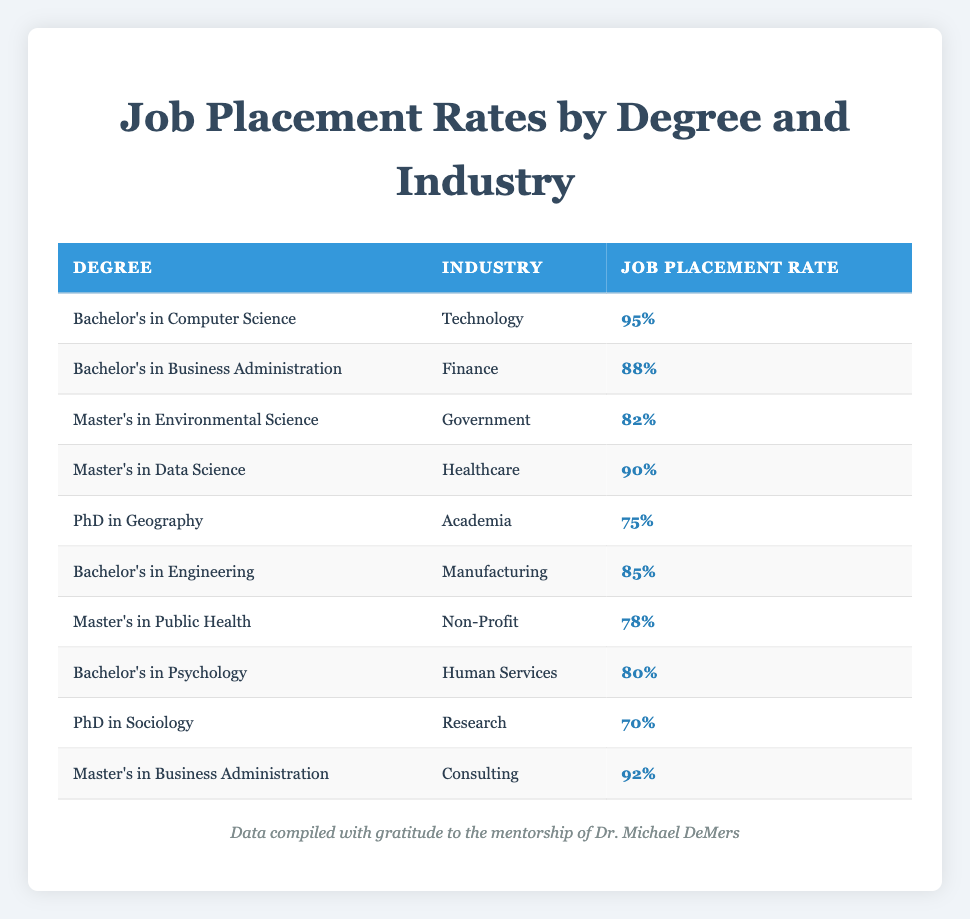What is the job placement rate for Bachelor's in Computer Science? The table lists the job placement rate for Bachelor's in Computer Science as 95%, which can be directly found in the corresponding row of the table.
Answer: 95% Which degree has the highest job placement rate? By examining the job placement rates in the table, Bachelor's in Computer Science has the highest rate of 95%, which is greater than all other rates listed.
Answer: Bachelor's in Computer Science What is the average job placement rate for Master's degrees? There are three Master's degrees listed: Environmental Science (82%), Data Science (90%), and Public Health (78%). Adding these rates gives 82 + 90 + 78 = 250. We then divide this sum by the number of Master's degrees, which is 3. Hence, the average is 250 / 3 = 83.33.
Answer: 83.33 Is the job placement rate for PhD in Geography greater than for PhD in Sociology? The table shows that the job placement rate for PhD in Geography is 75% and for PhD in Sociology is 70%. Since 75% is greater than 70%, the statement is true.
Answer: Yes How many degree categories have a job placement rate above 80%? We review the table: Bachelor's in Computer Science (95%), Bachelor's in Business Administration (88%), Master's in Data Science (90%), and Master's in Business Administration (92%) are the degrees above 80%. There are 4 degrees in total that meet this criterion.
Answer: 4 What is the difference in job placement rates between Bachelor's in Psychology and Master's in Public Health? The job placement rate for Bachelor's in Psychology is 80% and for Master's in Public Health is 78%. To find the difference, we subtract: 80 - 78 = 2.
Answer: 2 Does Master's in Business Administration have a higher job placement rate than Master's in Environmental Science? The table indicates that Master's in Business Administration has a job placement rate of 92% while Master's in Environmental Science has 82%. Since 92% is greater than 82%, the statement is true.
Answer: Yes Which industry has the lowest job placement rate among the listed degrees? By examining the table, the industry with the lowest job placement rate is Research, associated with the PhD in Sociology, which has a rate of 70%.
Answer: Research 